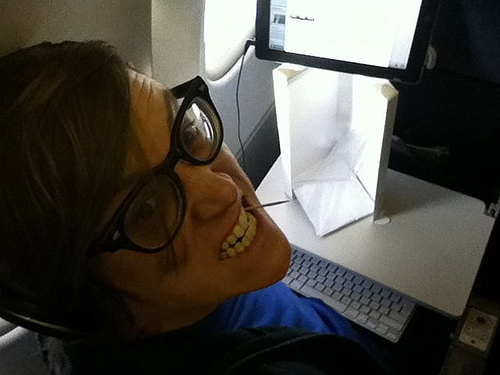Is the guy to the right or to the left of the book? The guy is to the left of the book. 